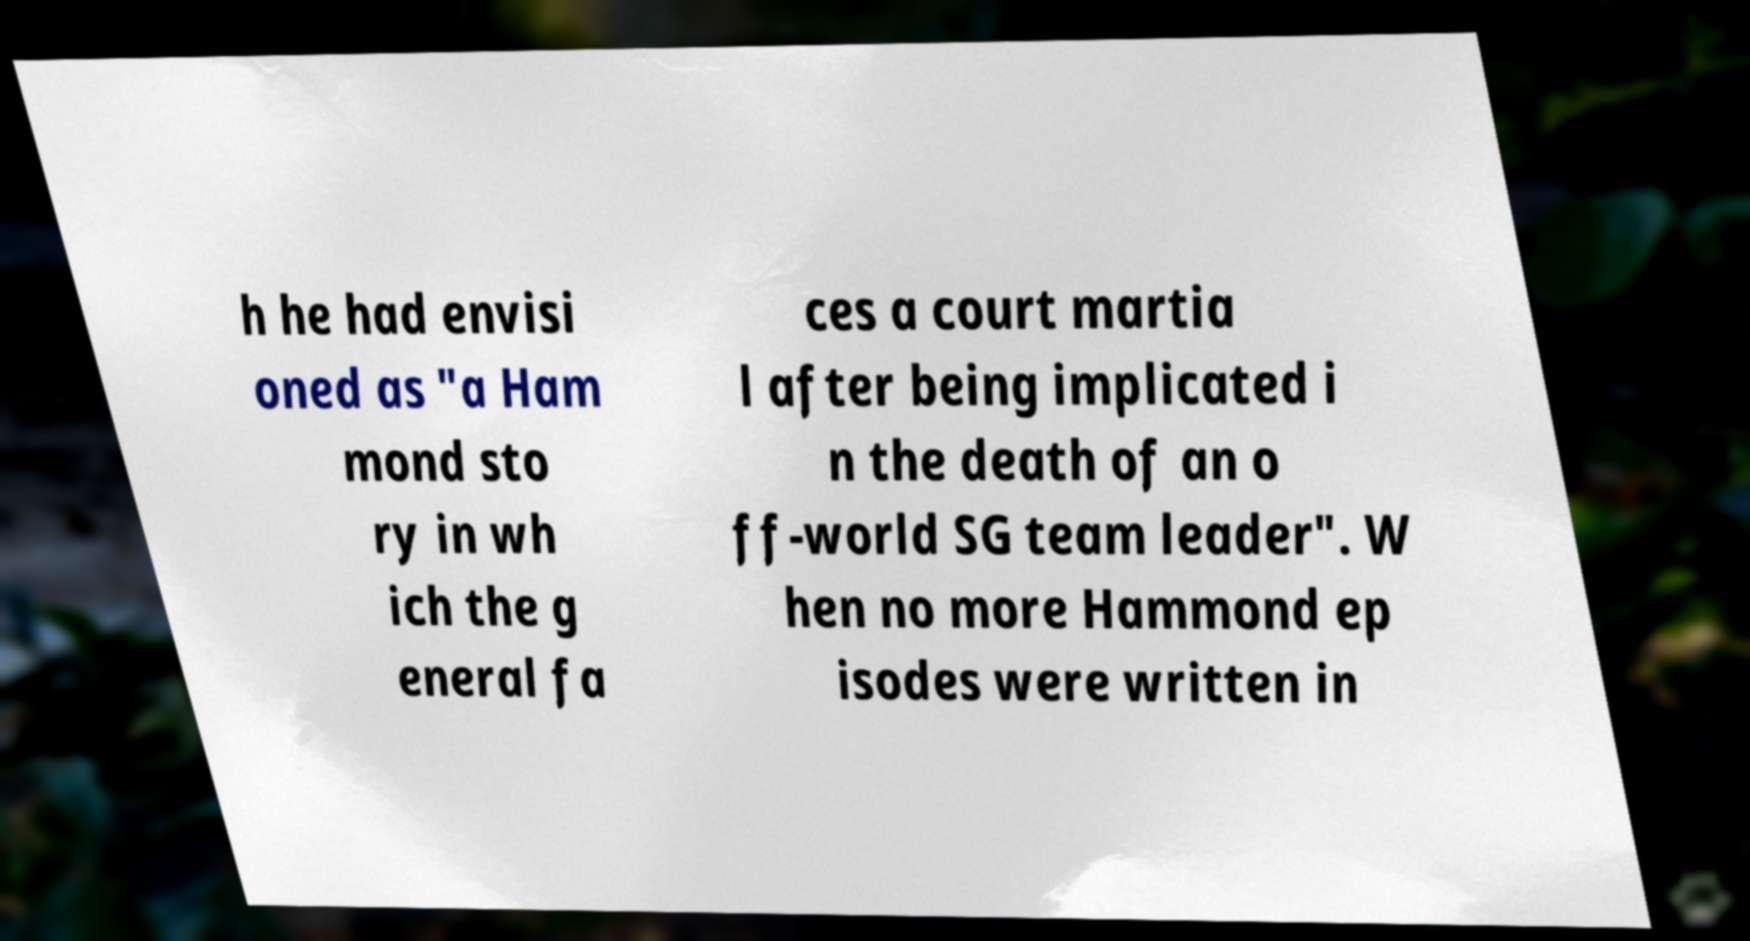Please read and relay the text visible in this image. What does it say? h he had envisi oned as "a Ham mond sto ry in wh ich the g eneral fa ces a court martia l after being implicated i n the death of an o ff-world SG team leader". W hen no more Hammond ep isodes were written in 